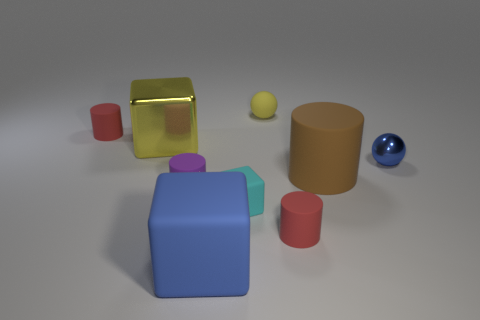Subtract all blue cubes. How many red cylinders are left? 2 Subtract all brown cylinders. How many cylinders are left? 3 Subtract all brown cylinders. How many cylinders are left? 3 Subtract 1 blocks. How many blocks are left? 2 Subtract all balls. How many objects are left? 7 Subtract all yellow cylinders. Subtract all cyan cubes. How many cylinders are left? 4 Subtract all large yellow matte objects. Subtract all tiny yellow rubber objects. How many objects are left? 8 Add 6 blue things. How many blue things are left? 8 Add 4 red matte objects. How many red matte objects exist? 6 Subtract 1 brown cylinders. How many objects are left? 8 